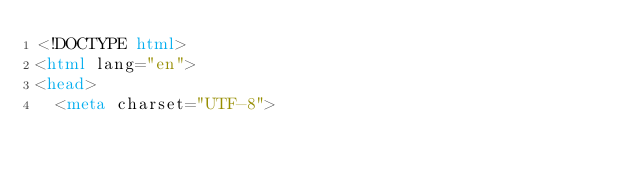Convert code to text. <code><loc_0><loc_0><loc_500><loc_500><_HTML_><!DOCTYPE html>
<html lang="en">
<head>
  <meta charset="UTF-8"></code> 